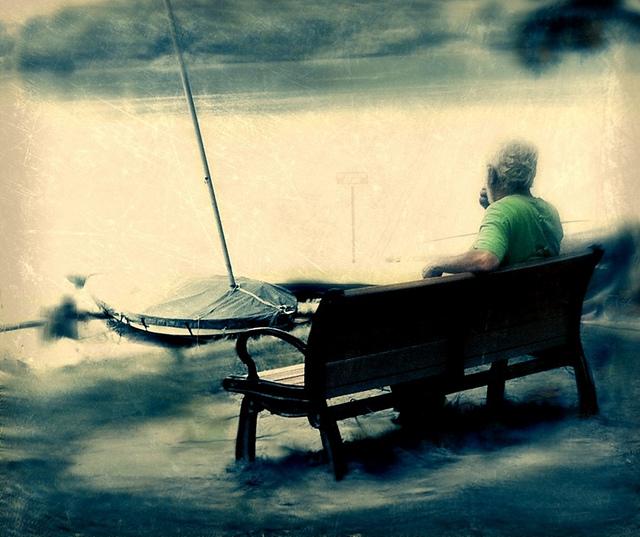Can you see water in the picture?
Keep it brief. Yes. Is this a color photo?
Short answer required. Yes. Where is the man sitting?
Keep it brief. Bench. What color is the man's shirt?
Write a very short answer. Green. 